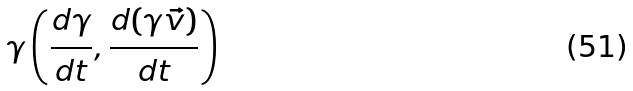Convert formula to latex. <formula><loc_0><loc_0><loc_500><loc_500>\gamma \left ( { \frac { d \gamma } { d t } } , { \frac { d ( \gamma { \vec { v } } ) } { d t } } \right )</formula> 